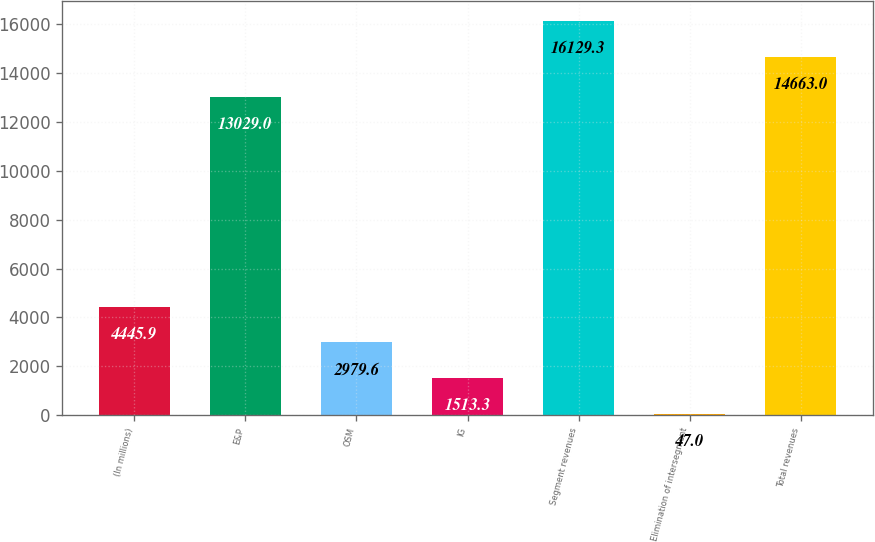Convert chart. <chart><loc_0><loc_0><loc_500><loc_500><bar_chart><fcel>(In millions)<fcel>E&P<fcel>OSM<fcel>IG<fcel>Segment revenues<fcel>Elimination of intersegment<fcel>Total revenues<nl><fcel>4445.9<fcel>13029<fcel>2979.6<fcel>1513.3<fcel>16129.3<fcel>47<fcel>14663<nl></chart> 